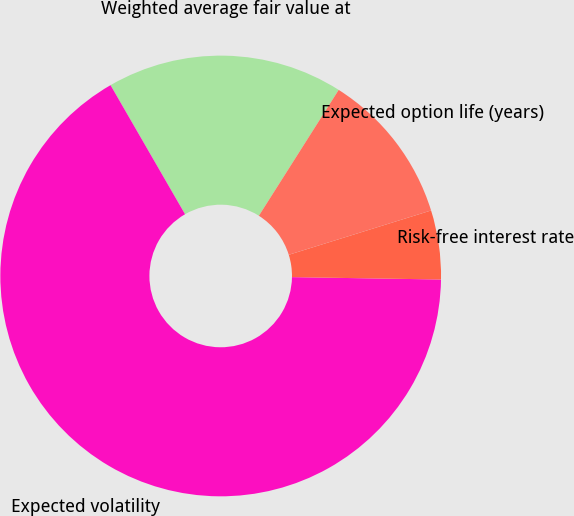Convert chart to OTSL. <chart><loc_0><loc_0><loc_500><loc_500><pie_chart><fcel>Weighted average fair value at<fcel>Expected volatility<fcel>Risk-free interest rate<fcel>Expected option life (years)<nl><fcel>17.33%<fcel>66.41%<fcel>5.06%<fcel>11.2%<nl></chart> 